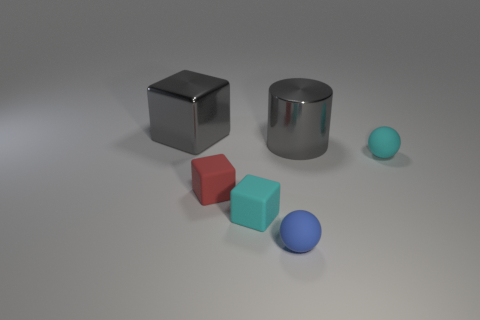Subtract all small blocks. How many blocks are left? 1 Add 1 big red cylinders. How many objects exist? 7 Subtract all spheres. How many objects are left? 4 Subtract 1 blue balls. How many objects are left? 5 Subtract all large objects. Subtract all blue objects. How many objects are left? 3 Add 3 tiny cyan objects. How many tiny cyan objects are left? 5 Add 4 cyan blocks. How many cyan blocks exist? 5 